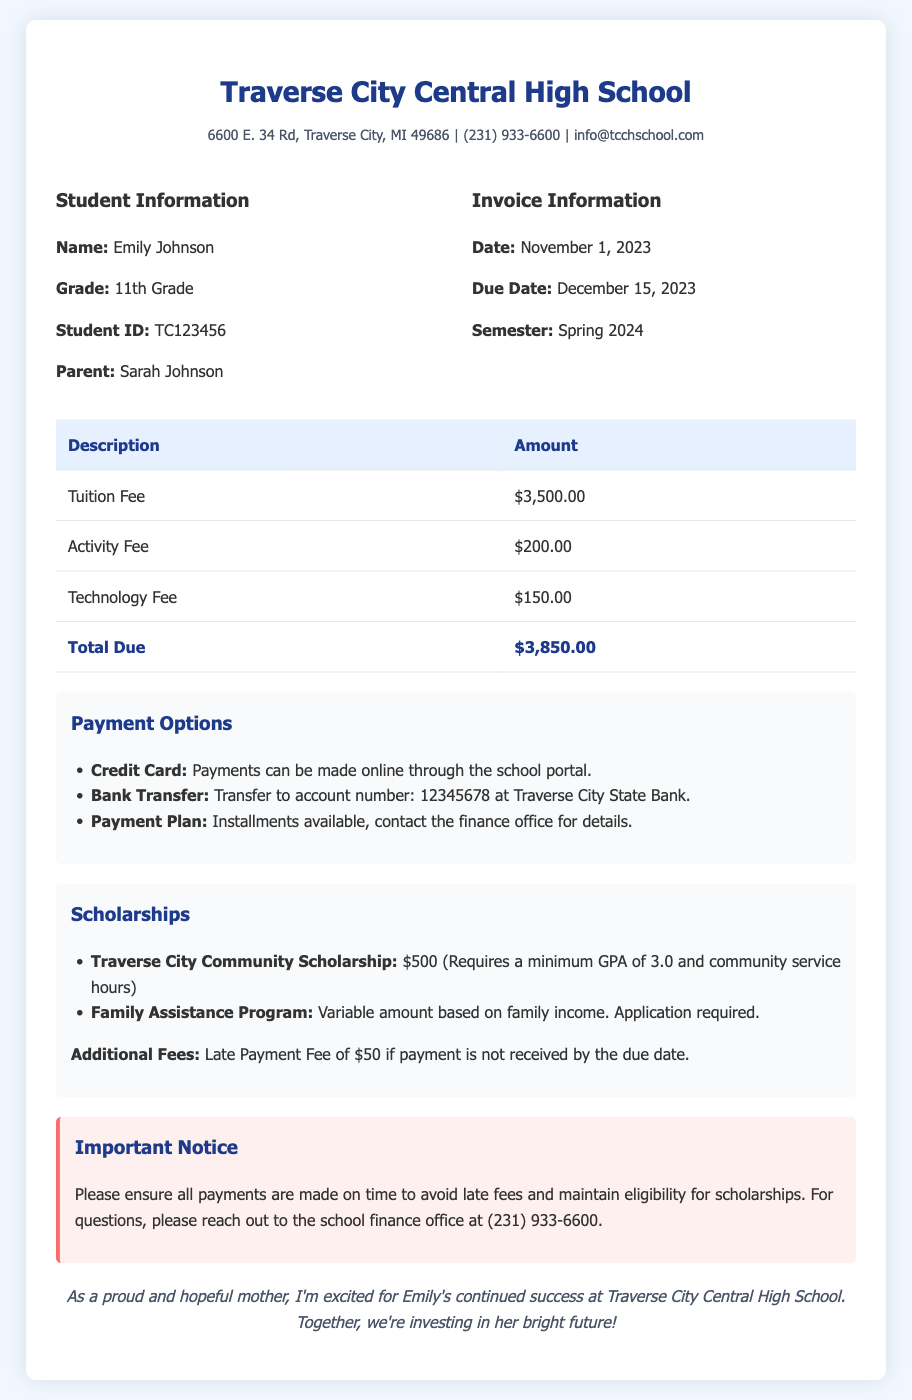What is the total amount due? The total amount due is calculated from the tuition fee, activity fee, and technology fee listed in the document.
Answer: $3,850.00 When is the due date for the payment? The due date for the payment is explicitly stated in the invoice details section of the document.
Answer: December 15, 2023 What is the amount of the tuition fee? The tuition fee is specified in the itemized list in the invoice.
Answer: $3,500.00 What scholarship requires a minimum GPA? This scholarship is named in the scholarships section of the document and specifies a minimum GPA requirement.
Answer: Traverse City Community Scholarship How can payments be made? The document outlines several methods for making payments, listed under the payment options section.
Answer: Credit Card, Bank Transfer, Payment Plan What is the late payment fee? The document mentions a specific fee that applies if payment is not received by the due date.
Answer: $50 What is the student's name? The student's name is provided in the student information section of the document.
Answer: Emily Johnson Which program requires an application based on family income? This program is specifically mentioned in the scholarships section, referring to financial eligibility.
Answer: Family Assistance Program What contact number is provided for the finance office? The contact number for the finance office is listed in the important notice section.
Answer: (231) 933-6600 